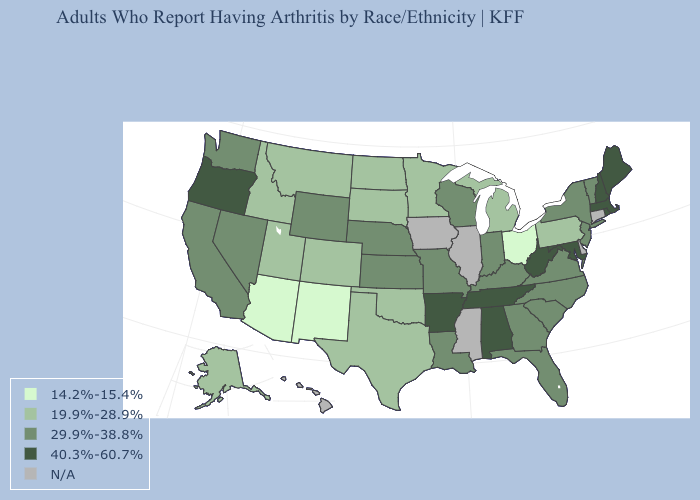What is the value of Ohio?
Concise answer only. 14.2%-15.4%. Among the states that border Kansas , does Nebraska have the highest value?
Write a very short answer. Yes. What is the value of Georgia?
Be succinct. 29.9%-38.8%. Among the states that border Texas , which have the lowest value?
Quick response, please. New Mexico. Name the states that have a value in the range N/A?
Write a very short answer. Connecticut, Delaware, Hawaii, Illinois, Iowa, Mississippi. How many symbols are there in the legend?
Write a very short answer. 5. Does the first symbol in the legend represent the smallest category?
Be succinct. Yes. Name the states that have a value in the range 19.9%-28.9%?
Be succinct. Alaska, Colorado, Idaho, Michigan, Minnesota, Montana, North Dakota, Oklahoma, Pennsylvania, South Dakota, Texas, Utah. Which states have the lowest value in the USA?
Give a very brief answer. Arizona, New Mexico, Ohio. Name the states that have a value in the range N/A?
Short answer required. Connecticut, Delaware, Hawaii, Illinois, Iowa, Mississippi. Name the states that have a value in the range 14.2%-15.4%?
Quick response, please. Arizona, New Mexico, Ohio. Name the states that have a value in the range 14.2%-15.4%?
Quick response, please. Arizona, New Mexico, Ohio. Does Tennessee have the lowest value in the USA?
Write a very short answer. No. What is the highest value in states that border Indiana?
Answer briefly. 29.9%-38.8%. Name the states that have a value in the range 40.3%-60.7%?
Answer briefly. Alabama, Arkansas, Maine, Maryland, Massachusetts, New Hampshire, Oregon, Rhode Island, Tennessee, West Virginia. 